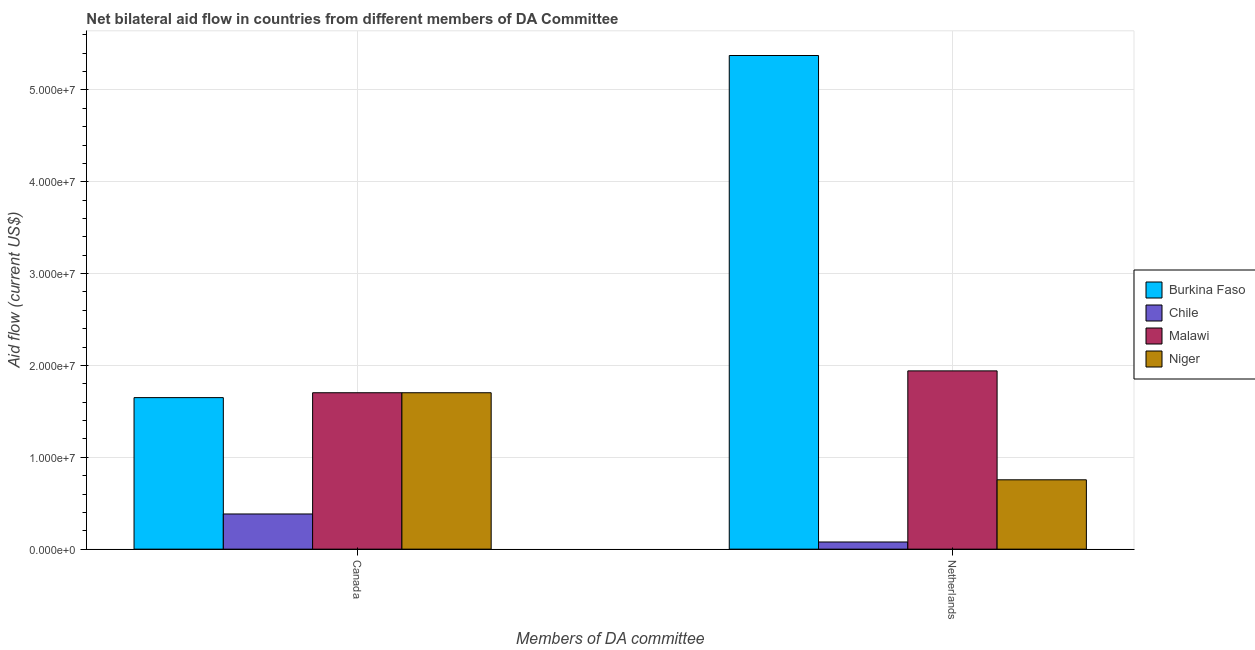How many groups of bars are there?
Keep it short and to the point. 2. How many bars are there on the 2nd tick from the left?
Provide a short and direct response. 4. How many bars are there on the 2nd tick from the right?
Your response must be concise. 4. What is the label of the 2nd group of bars from the left?
Provide a short and direct response. Netherlands. What is the amount of aid given by netherlands in Burkina Faso?
Offer a terse response. 5.38e+07. Across all countries, what is the maximum amount of aid given by canada?
Your answer should be compact. 1.70e+07. Across all countries, what is the minimum amount of aid given by netherlands?
Give a very brief answer. 7.80e+05. In which country was the amount of aid given by netherlands maximum?
Your answer should be very brief. Burkina Faso. In which country was the amount of aid given by netherlands minimum?
Give a very brief answer. Chile. What is the total amount of aid given by netherlands in the graph?
Your response must be concise. 8.15e+07. What is the difference between the amount of aid given by netherlands in Malawi and that in Niger?
Provide a short and direct response. 1.19e+07. What is the difference between the amount of aid given by netherlands in Niger and the amount of aid given by canada in Malawi?
Your answer should be compact. -9.48e+06. What is the average amount of aid given by netherlands per country?
Your response must be concise. 2.04e+07. What is the difference between the amount of aid given by canada and amount of aid given by netherlands in Burkina Faso?
Make the answer very short. -3.72e+07. What is the ratio of the amount of aid given by netherlands in Burkina Faso to that in Niger?
Ensure brevity in your answer.  7.12. Is the amount of aid given by netherlands in Malawi less than that in Burkina Faso?
Your answer should be very brief. Yes. What does the 3rd bar from the left in Netherlands represents?
Provide a succinct answer. Malawi. What does the 4th bar from the right in Netherlands represents?
Provide a short and direct response. Burkina Faso. How many bars are there?
Your answer should be very brief. 8. How many countries are there in the graph?
Offer a very short reply. 4. Are the values on the major ticks of Y-axis written in scientific E-notation?
Keep it short and to the point. Yes. What is the title of the graph?
Give a very brief answer. Net bilateral aid flow in countries from different members of DA Committee. What is the label or title of the X-axis?
Provide a succinct answer. Members of DA committee. What is the label or title of the Y-axis?
Make the answer very short. Aid flow (current US$). What is the Aid flow (current US$) in Burkina Faso in Canada?
Your answer should be compact. 1.65e+07. What is the Aid flow (current US$) of Chile in Canada?
Your answer should be very brief. 3.83e+06. What is the Aid flow (current US$) in Malawi in Canada?
Your answer should be very brief. 1.70e+07. What is the Aid flow (current US$) in Niger in Canada?
Keep it short and to the point. 1.70e+07. What is the Aid flow (current US$) of Burkina Faso in Netherlands?
Provide a succinct answer. 5.38e+07. What is the Aid flow (current US$) in Chile in Netherlands?
Offer a terse response. 7.80e+05. What is the Aid flow (current US$) in Malawi in Netherlands?
Give a very brief answer. 1.94e+07. What is the Aid flow (current US$) of Niger in Netherlands?
Provide a short and direct response. 7.55e+06. Across all Members of DA committee, what is the maximum Aid flow (current US$) in Burkina Faso?
Offer a very short reply. 5.38e+07. Across all Members of DA committee, what is the maximum Aid flow (current US$) of Chile?
Give a very brief answer. 3.83e+06. Across all Members of DA committee, what is the maximum Aid flow (current US$) of Malawi?
Provide a succinct answer. 1.94e+07. Across all Members of DA committee, what is the maximum Aid flow (current US$) in Niger?
Your answer should be compact. 1.70e+07. Across all Members of DA committee, what is the minimum Aid flow (current US$) in Burkina Faso?
Your answer should be compact. 1.65e+07. Across all Members of DA committee, what is the minimum Aid flow (current US$) in Chile?
Keep it short and to the point. 7.80e+05. Across all Members of DA committee, what is the minimum Aid flow (current US$) in Malawi?
Keep it short and to the point. 1.70e+07. Across all Members of DA committee, what is the minimum Aid flow (current US$) in Niger?
Your answer should be compact. 7.55e+06. What is the total Aid flow (current US$) in Burkina Faso in the graph?
Keep it short and to the point. 7.02e+07. What is the total Aid flow (current US$) of Chile in the graph?
Make the answer very short. 4.61e+06. What is the total Aid flow (current US$) of Malawi in the graph?
Offer a terse response. 3.64e+07. What is the total Aid flow (current US$) in Niger in the graph?
Make the answer very short. 2.46e+07. What is the difference between the Aid flow (current US$) of Burkina Faso in Canada and that in Netherlands?
Your answer should be very brief. -3.72e+07. What is the difference between the Aid flow (current US$) in Chile in Canada and that in Netherlands?
Offer a very short reply. 3.05e+06. What is the difference between the Aid flow (current US$) in Malawi in Canada and that in Netherlands?
Offer a very short reply. -2.38e+06. What is the difference between the Aid flow (current US$) in Niger in Canada and that in Netherlands?
Provide a short and direct response. 9.48e+06. What is the difference between the Aid flow (current US$) in Burkina Faso in Canada and the Aid flow (current US$) in Chile in Netherlands?
Ensure brevity in your answer.  1.57e+07. What is the difference between the Aid flow (current US$) in Burkina Faso in Canada and the Aid flow (current US$) in Malawi in Netherlands?
Your answer should be very brief. -2.91e+06. What is the difference between the Aid flow (current US$) of Burkina Faso in Canada and the Aid flow (current US$) of Niger in Netherlands?
Keep it short and to the point. 8.95e+06. What is the difference between the Aid flow (current US$) of Chile in Canada and the Aid flow (current US$) of Malawi in Netherlands?
Provide a short and direct response. -1.56e+07. What is the difference between the Aid flow (current US$) in Chile in Canada and the Aid flow (current US$) in Niger in Netherlands?
Make the answer very short. -3.72e+06. What is the difference between the Aid flow (current US$) in Malawi in Canada and the Aid flow (current US$) in Niger in Netherlands?
Your response must be concise. 9.48e+06. What is the average Aid flow (current US$) in Burkina Faso per Members of DA committee?
Your answer should be compact. 3.51e+07. What is the average Aid flow (current US$) of Chile per Members of DA committee?
Your answer should be compact. 2.30e+06. What is the average Aid flow (current US$) of Malawi per Members of DA committee?
Give a very brief answer. 1.82e+07. What is the average Aid flow (current US$) of Niger per Members of DA committee?
Offer a terse response. 1.23e+07. What is the difference between the Aid flow (current US$) of Burkina Faso and Aid flow (current US$) of Chile in Canada?
Your answer should be very brief. 1.27e+07. What is the difference between the Aid flow (current US$) in Burkina Faso and Aid flow (current US$) in Malawi in Canada?
Make the answer very short. -5.30e+05. What is the difference between the Aid flow (current US$) of Burkina Faso and Aid flow (current US$) of Niger in Canada?
Keep it short and to the point. -5.30e+05. What is the difference between the Aid flow (current US$) in Chile and Aid flow (current US$) in Malawi in Canada?
Your answer should be very brief. -1.32e+07. What is the difference between the Aid flow (current US$) in Chile and Aid flow (current US$) in Niger in Canada?
Keep it short and to the point. -1.32e+07. What is the difference between the Aid flow (current US$) of Malawi and Aid flow (current US$) of Niger in Canada?
Offer a very short reply. 0. What is the difference between the Aid flow (current US$) of Burkina Faso and Aid flow (current US$) of Chile in Netherlands?
Offer a very short reply. 5.30e+07. What is the difference between the Aid flow (current US$) of Burkina Faso and Aid flow (current US$) of Malawi in Netherlands?
Ensure brevity in your answer.  3.43e+07. What is the difference between the Aid flow (current US$) of Burkina Faso and Aid flow (current US$) of Niger in Netherlands?
Provide a short and direct response. 4.62e+07. What is the difference between the Aid flow (current US$) of Chile and Aid flow (current US$) of Malawi in Netherlands?
Your response must be concise. -1.86e+07. What is the difference between the Aid flow (current US$) of Chile and Aid flow (current US$) of Niger in Netherlands?
Make the answer very short. -6.77e+06. What is the difference between the Aid flow (current US$) in Malawi and Aid flow (current US$) in Niger in Netherlands?
Ensure brevity in your answer.  1.19e+07. What is the ratio of the Aid flow (current US$) of Burkina Faso in Canada to that in Netherlands?
Your response must be concise. 0.31. What is the ratio of the Aid flow (current US$) of Chile in Canada to that in Netherlands?
Keep it short and to the point. 4.91. What is the ratio of the Aid flow (current US$) in Malawi in Canada to that in Netherlands?
Provide a succinct answer. 0.88. What is the ratio of the Aid flow (current US$) in Niger in Canada to that in Netherlands?
Make the answer very short. 2.26. What is the difference between the highest and the second highest Aid flow (current US$) in Burkina Faso?
Make the answer very short. 3.72e+07. What is the difference between the highest and the second highest Aid flow (current US$) in Chile?
Provide a short and direct response. 3.05e+06. What is the difference between the highest and the second highest Aid flow (current US$) in Malawi?
Offer a very short reply. 2.38e+06. What is the difference between the highest and the second highest Aid flow (current US$) in Niger?
Offer a very short reply. 9.48e+06. What is the difference between the highest and the lowest Aid flow (current US$) of Burkina Faso?
Make the answer very short. 3.72e+07. What is the difference between the highest and the lowest Aid flow (current US$) in Chile?
Your answer should be very brief. 3.05e+06. What is the difference between the highest and the lowest Aid flow (current US$) of Malawi?
Make the answer very short. 2.38e+06. What is the difference between the highest and the lowest Aid flow (current US$) in Niger?
Your answer should be compact. 9.48e+06. 